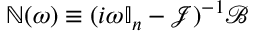<formula> <loc_0><loc_0><loc_500><loc_500>\mathbb { N } ( \omega ) \equiv ( i \omega \mathbb { I } _ { n } - \mathcal { J } ) ^ { - 1 } \mathcal { B }</formula> 